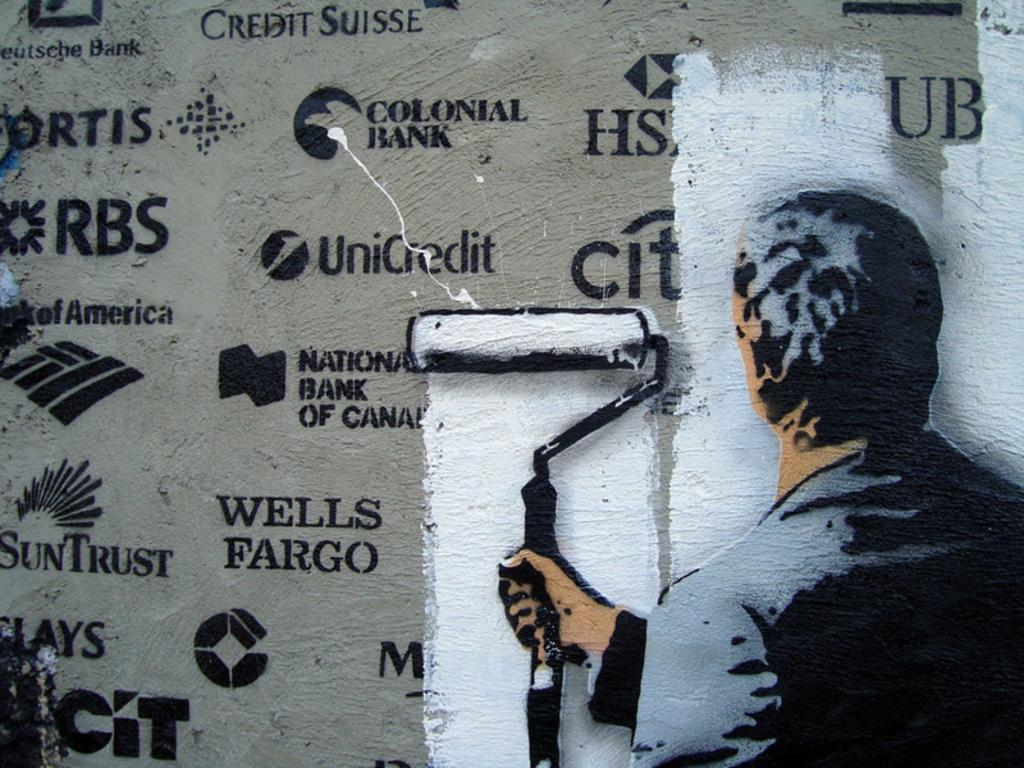<image>
Present a compact description of the photo's key features. A painting of someone painting over logos such as Wells Fargo. 